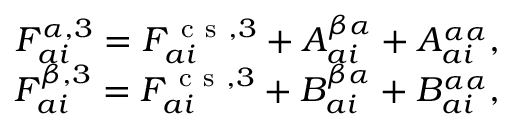<formula> <loc_0><loc_0><loc_500><loc_500>\begin{array} { r } { F _ { a i } ^ { \alpha , 3 } = F _ { a i } ^ { c s , 3 } + A _ { a i } ^ { \beta \alpha } + A _ { a i } ^ { \alpha \alpha } , } \\ { F _ { a i } ^ { \beta , 3 } = F _ { a i } ^ { c s , 3 } + B _ { a i } ^ { \beta \alpha } + B _ { a i } ^ { \alpha \alpha } , } \end{array}</formula> 